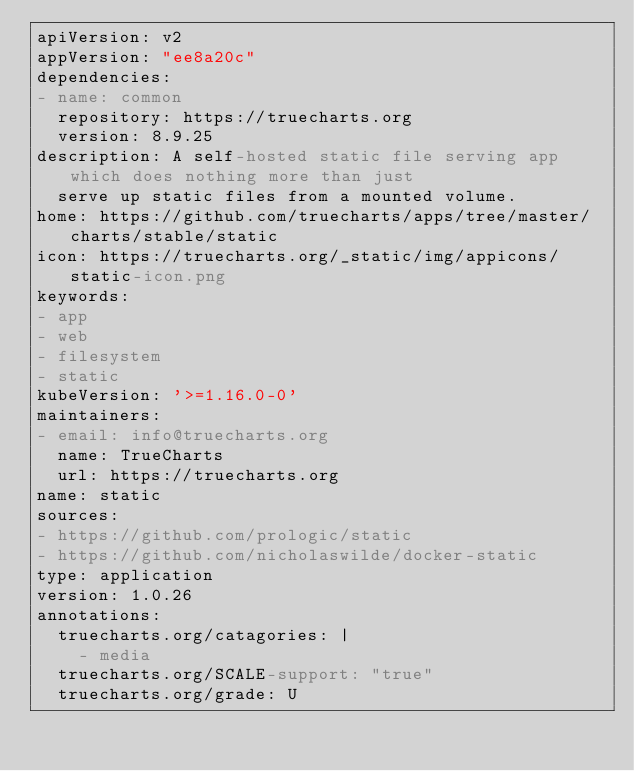Convert code to text. <code><loc_0><loc_0><loc_500><loc_500><_YAML_>apiVersion: v2
appVersion: "ee8a20c"
dependencies:
- name: common
  repository: https://truecharts.org
  version: 8.9.25
description: A self-hosted static file serving app which does nothing more than just
  serve up static files from a mounted volume.
home: https://github.com/truecharts/apps/tree/master/charts/stable/static
icon: https://truecharts.org/_static/img/appicons/static-icon.png
keywords:
- app
- web
- filesystem
- static
kubeVersion: '>=1.16.0-0'
maintainers:
- email: info@truecharts.org
  name: TrueCharts
  url: https://truecharts.org
name: static
sources:
- https://github.com/prologic/static
- https://github.com/nicholaswilde/docker-static
type: application
version: 1.0.26
annotations:
  truecharts.org/catagories: |
    - media
  truecharts.org/SCALE-support: "true"
  truecharts.org/grade: U
</code> 